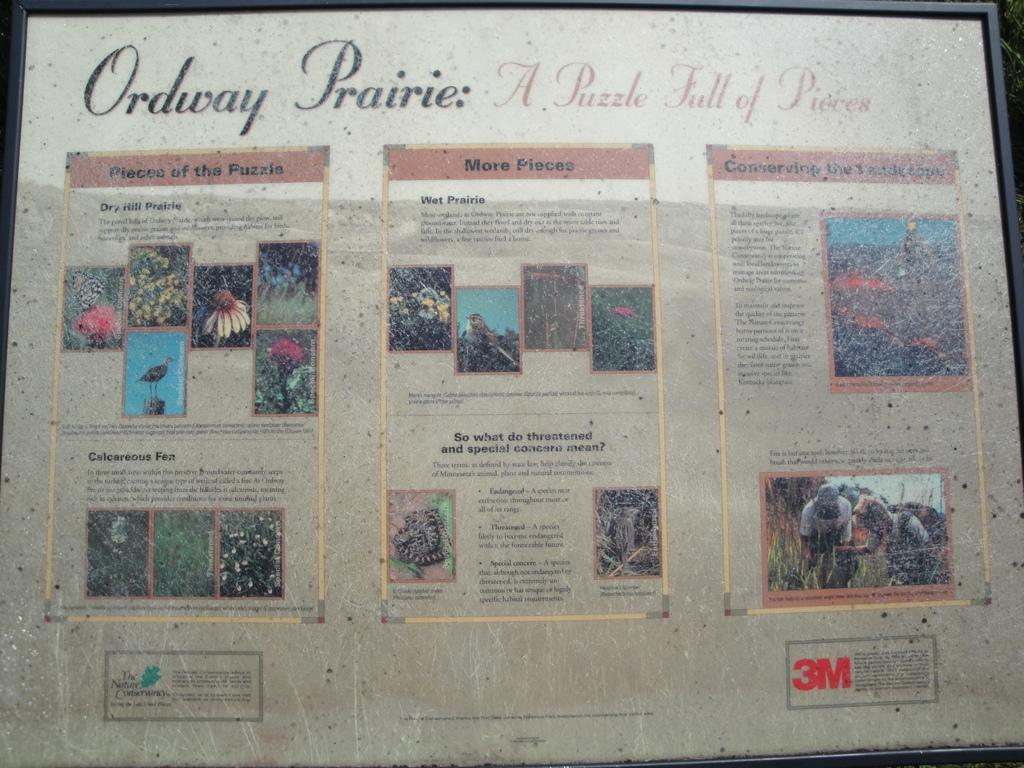<image>
Provide a brief description of the given image. A print image titled Ordway Prairie with pictures of flowers on it. 